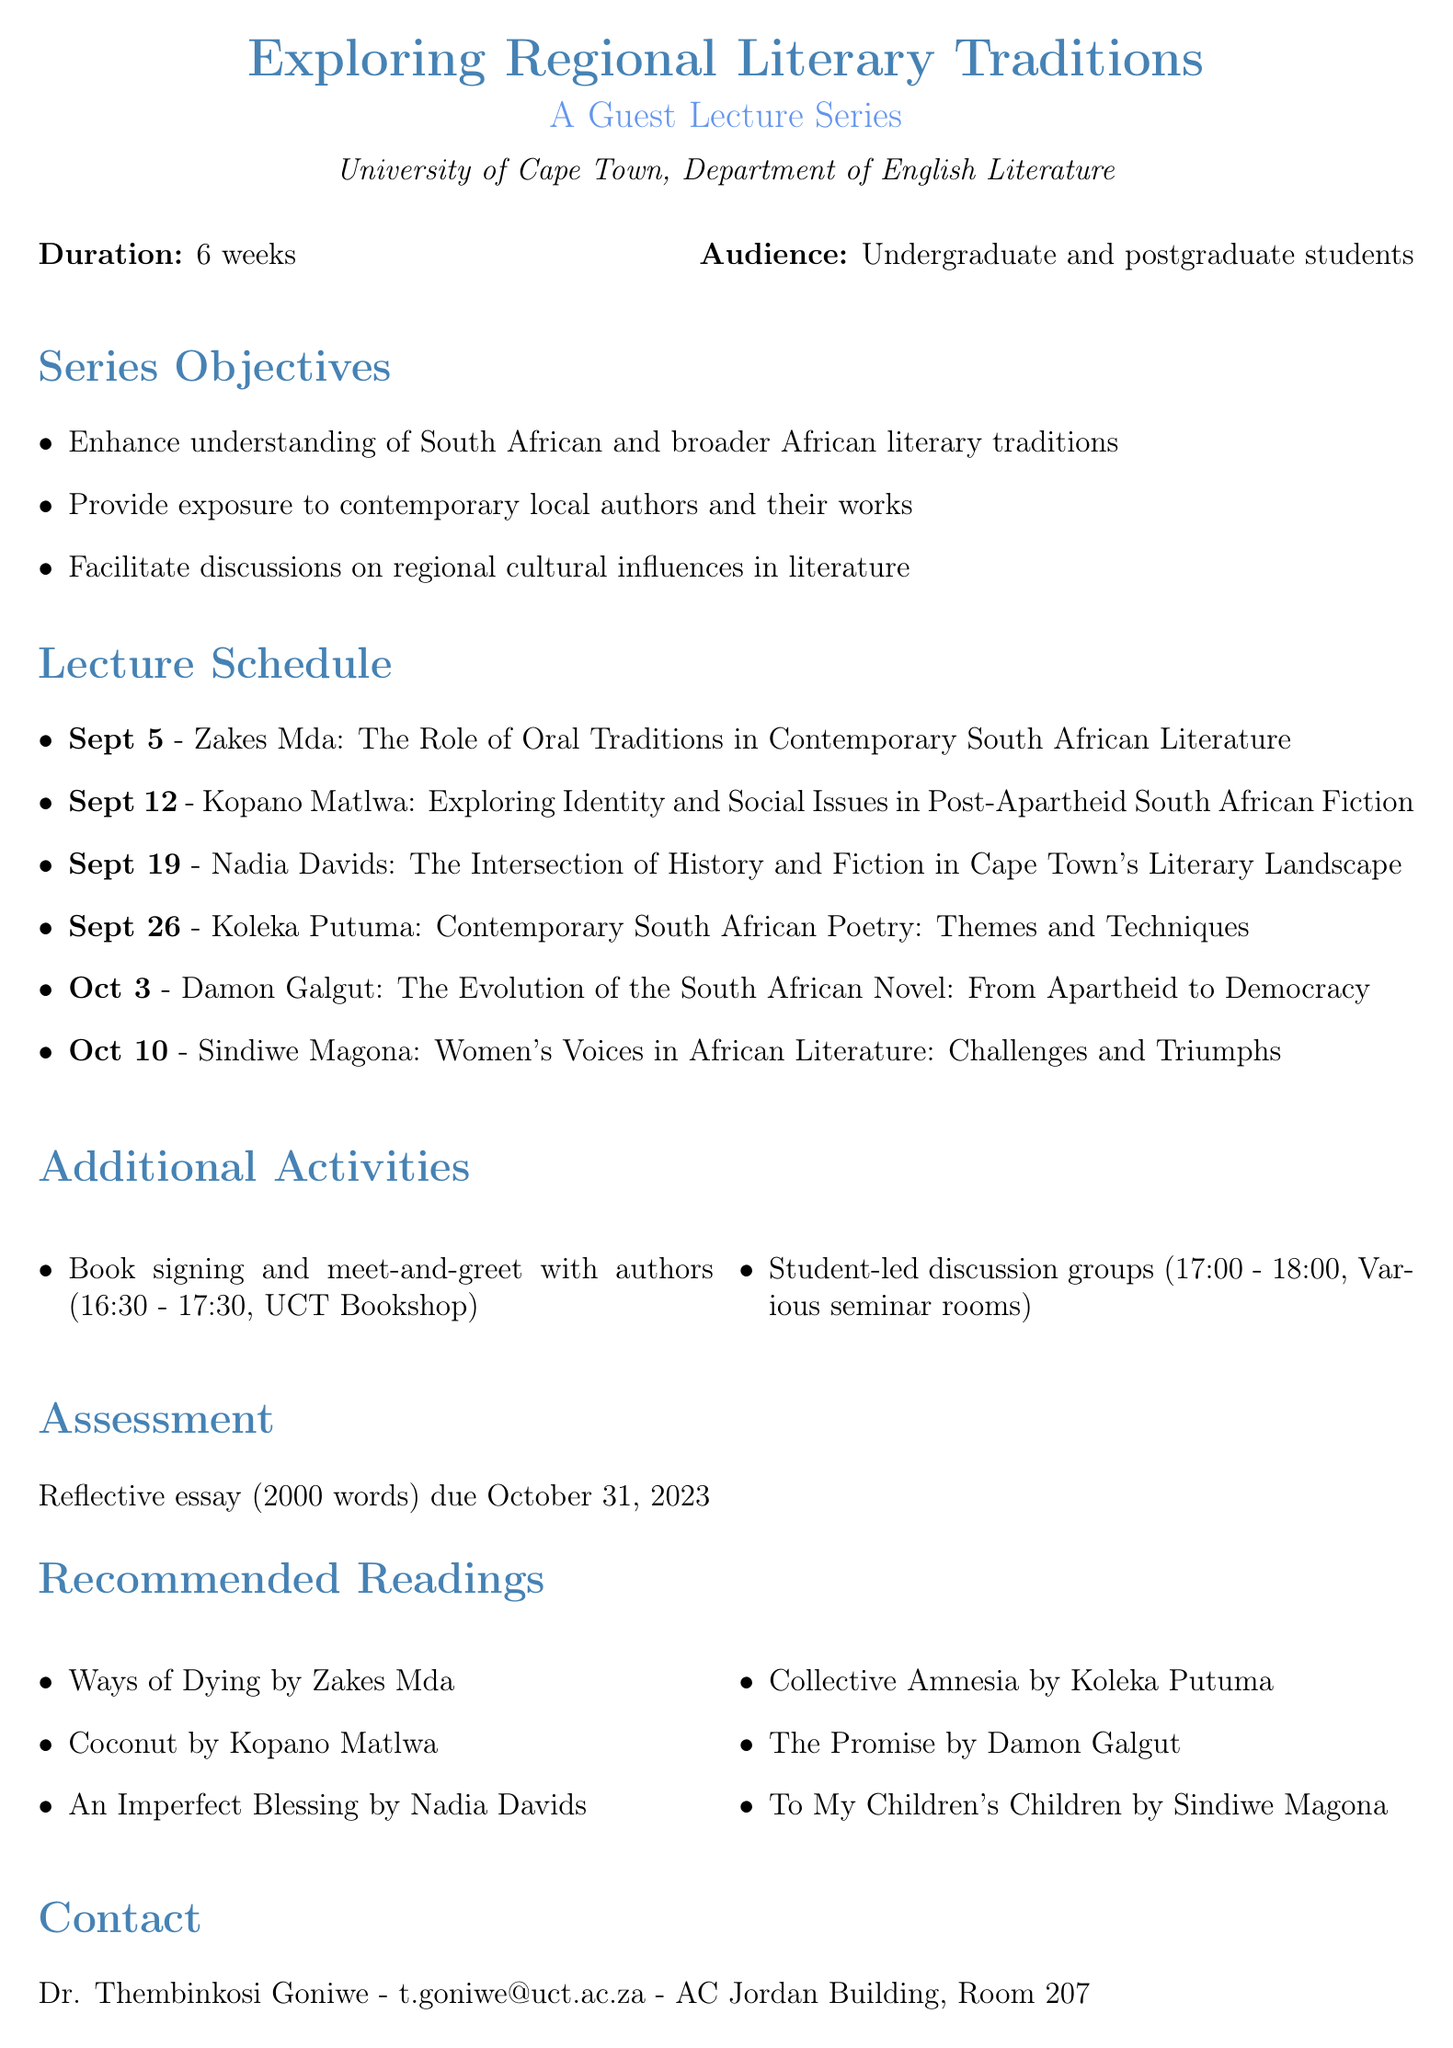What is the title of the lecture series? The title of the lecture series is stated in the document as "Exploring Regional Literary Traditions: A Guest Lecture Series."
Answer: Exploring Regional Literary Traditions: A Guest Lecture Series How long is the series duration? The duration of the series is explicitly mentioned as "6 weeks."
Answer: 6 weeks What is the target audience for the lectures? The document specifies that the target audience includes "Undergraduate and postgraduate students of literature."
Answer: Undergraduate and postgraduate students of literature On what date is Zakes Mda's lecture scheduled? The exact date for Zakes Mda's lecture can be found in the schedule, which states "September 5, 2023."
Answer: September 5, 2023 What is the location for Damon Galgut's lecture? The venue for Damon Galgut's lecture is listed as "Jameson Hall."
Answer: Jameson Hall Which activity follows each lecture? The document indicates that a "Book signing and meet-and-greet with authors" occurs immediately after each lecture.
Answer: Book signing and meet-and-greet with authors What is the word count for the reflective essay? The required word count for the reflective essay is explicitly mentioned as "2000."
Answer: 2000 Who is the coordinator of the lecture series? The name of the coordinator is mentioned as "Dr. Thembinkosi Goniwe."
Answer: Dr. Thembinkosi Goniwe What topics will be covered in the series? Each guest lecturer's topic provides insights into the series content, for example, "The Role of Oral Traditions in Contemporary South African Literature."
Answer: The Role of Oral Traditions in Contemporary South African Literature 